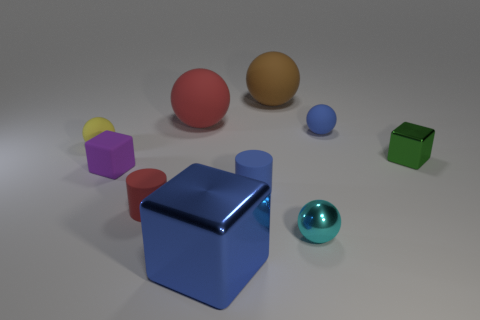Are the objects arranged in any particular pattern or order? Not in an immediately discernible pattern; the objects are scattered randomly across the surface. However, they are neatly spaced and do not overlap, which could indicate an intentional arrangement, possibly for display or an artistic composition. 